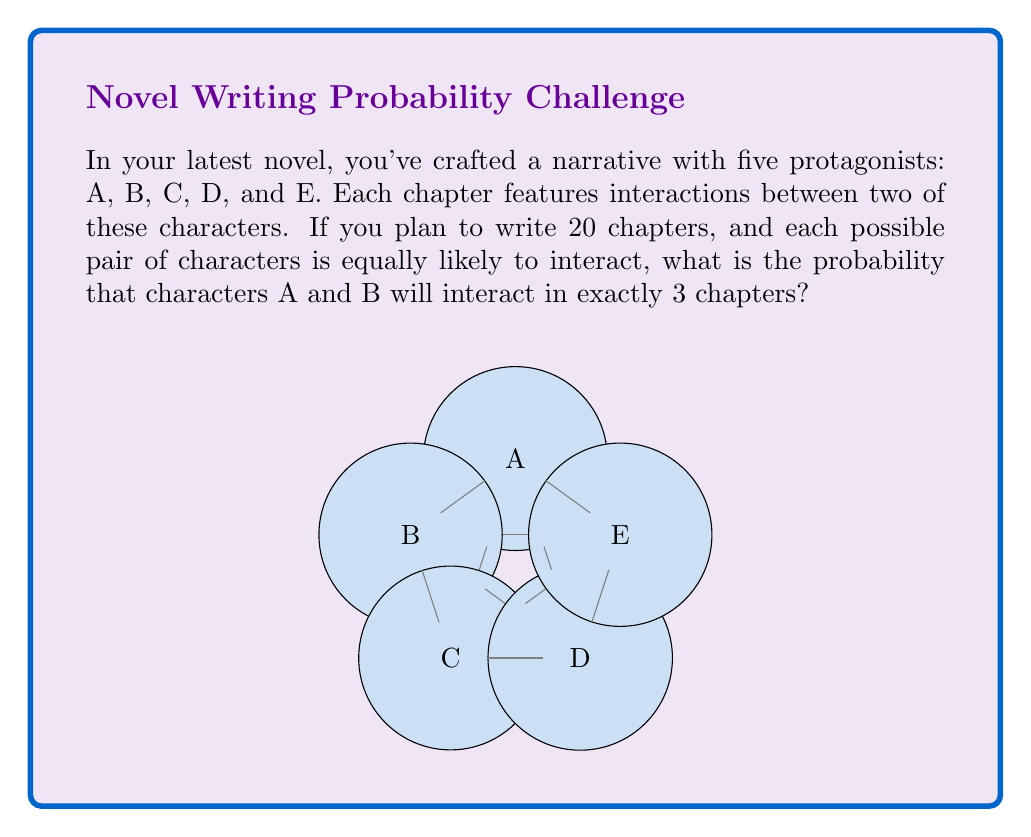Show me your answer to this math problem. To solve this problem, we'll use the binomial probability distribution. Let's break it down step-by-step:

1) First, we need to calculate the probability of A and B interacting in a single chapter.
   - There are $\binom{5}{2} = 10$ possible pairs of characters.
   - The probability of A and B interacting in a single chapter is $p = \frac{1}{10}$.

2) We want the probability of exactly 3 interactions in 20 chapters. This follows a binomial distribution with parameters $n = 20$ (number of chapters) and $p = \frac{1}{10}$ (probability of A and B interacting in a single chapter).

3) The probability mass function for a binomial distribution is:

   $$P(X = k) = \binom{n}{k} p^k (1-p)^{n-k}$$

   where $n$ is the number of trials, $k$ is the number of successes, and $p$ is the probability of success on a single trial.

4) In our case, $n = 20$, $k = 3$, and $p = \frac{1}{10}$. Let's substitute these values:

   $$P(X = 3) = \binom{20}{3} (\frac{1}{10})^3 (1-\frac{1}{10})^{20-3}$$

5) Simplify:
   $$P(X = 3) = 1140 \cdot (\frac{1}{1000}) \cdot (\frac{9}{10})^{17}$$

6) Calculate:
   $$P(X = 3) \approx 0.1827$$

Therefore, the probability of characters A and B interacting in exactly 3 out of 20 chapters is approximately 0.1827 or 18.27%.
Answer: $0.1827$ or $18.27\%$ 